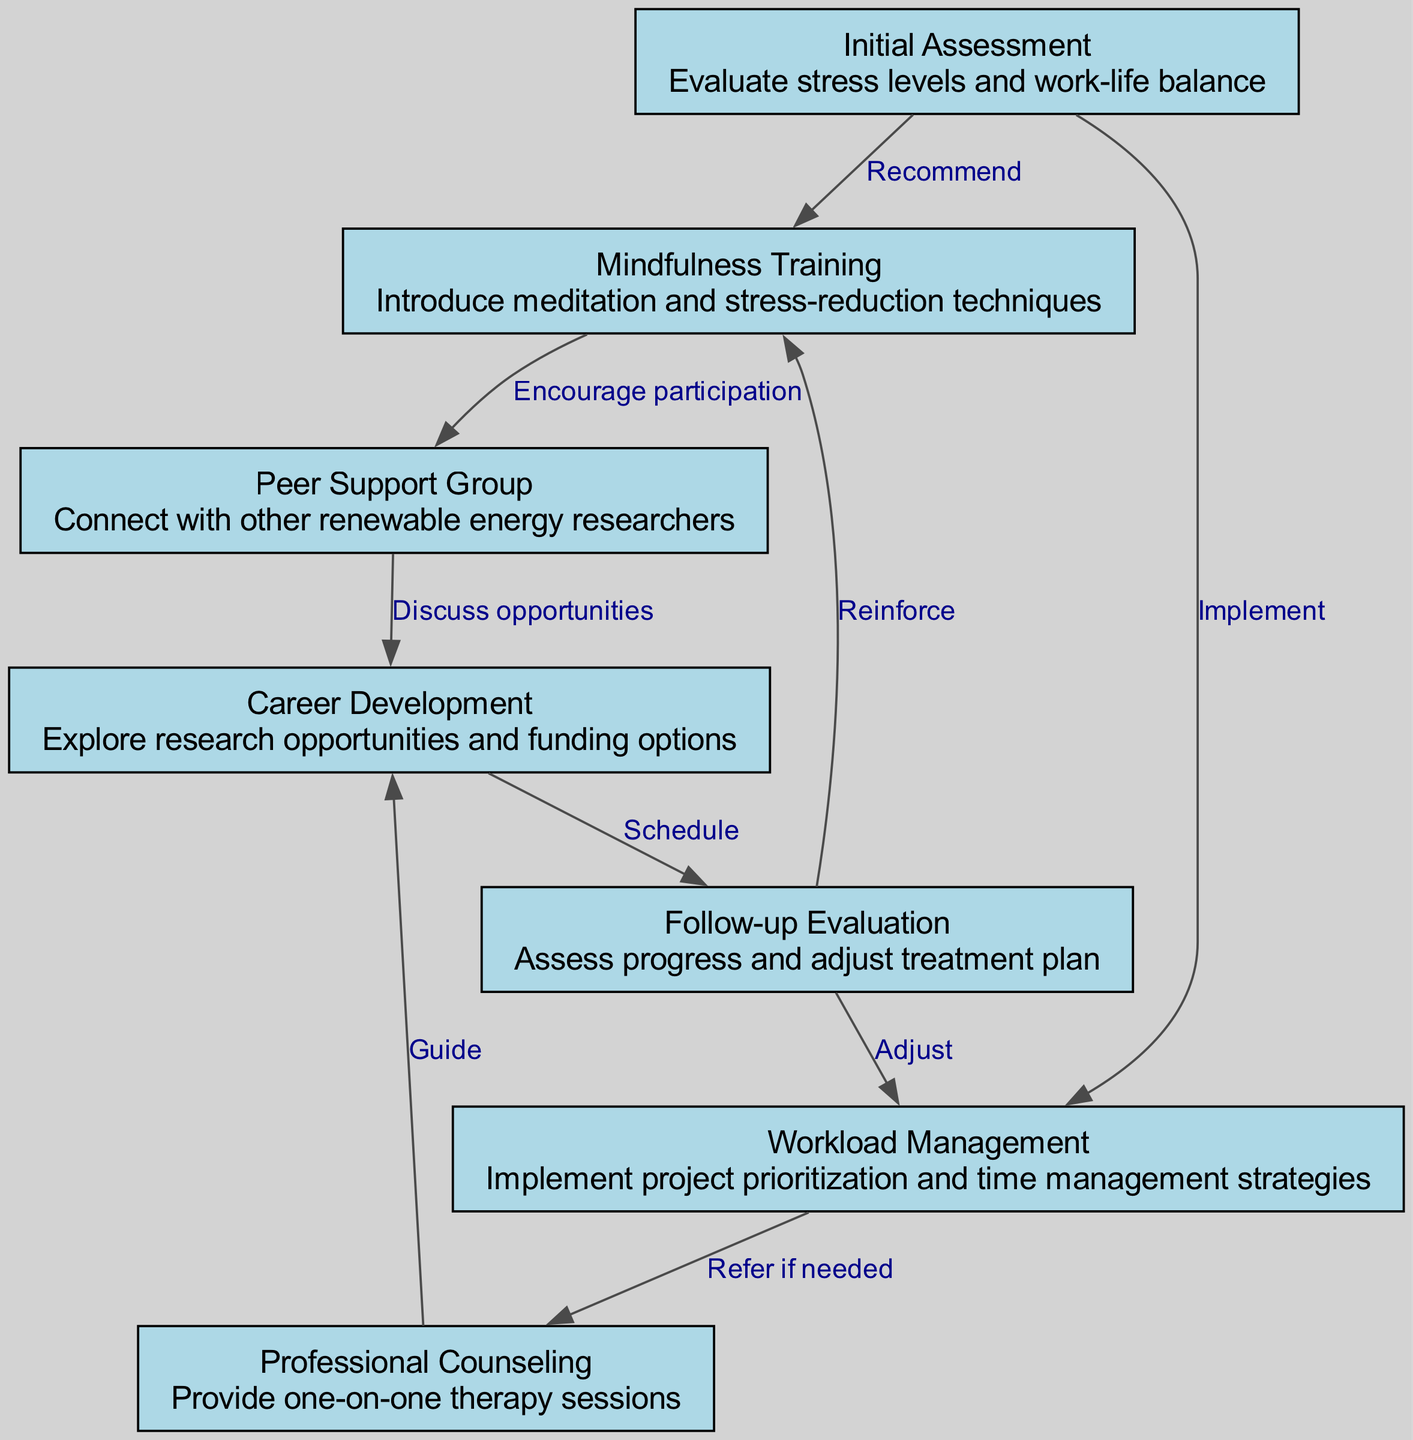What is the first step in the clinical pathway? The diagram shows "Initial Assessment" as the first node, which indicates the starting step of the clinical pathway.
Answer: Initial Assessment How many nodes are in the diagram? Counting all the distinct nodes listed, there are a total of 7 nodes represented in the diagram.
Answer: 7 What does the edge from "Workload Management" to "Professional Counseling" indicate? The edge labeled "Refer if needed" shows that if workload management strategies are insufficient, a referral to professional counseling is advised.
Answer: Refer if needed Which node connects Peer Support Group to Career Development? The edge from "Peer Support Group" to "Career Development" is labeled "Discuss opportunities," indicating a link between connecting with peers and exploring career opportunities.
Answer: Discuss opportunities What is the label of the edge from "Follow-up Evaluation" to "Mindfulness Training"? The diagram indicates an edge from "Follow-up Evaluation" to "Mindfulness Training" labeled "Reinforce," showing an ongoing emphasis on mindfulness practices after evaluation.
Answer: Reinforce How many edges were drawn between nodes in the diagram? By counting all the connections (edges) listed in the diagram, there are 8 edges illustrating relationships between nodes.
Answer: 8 What action occurs after the "Follow-up Evaluation"? The diagram indicates that following the "Follow-up Evaluation," there is an action to "Reinforce" mindfulness training and "Adjust" workload management strategies.
Answer: Reinforce and Adjust Which node is reached after receiving recommendations from the "Initial Assessment"? The connections show that from "Initial Assessment," the next nodes can be either "Mindfulness Training" or "Workload Management," indicating two possible paths to follow.
Answer: Mindfulness Training or Workload Management How does "Peer Support Group" lead to "Career Development"? The edge from "Peer Support Group" to "Career Development" is labeled "Discuss opportunities," suggesting that discussions within the peer group may open up avenues for career advancement.
Answer: Discuss opportunities 